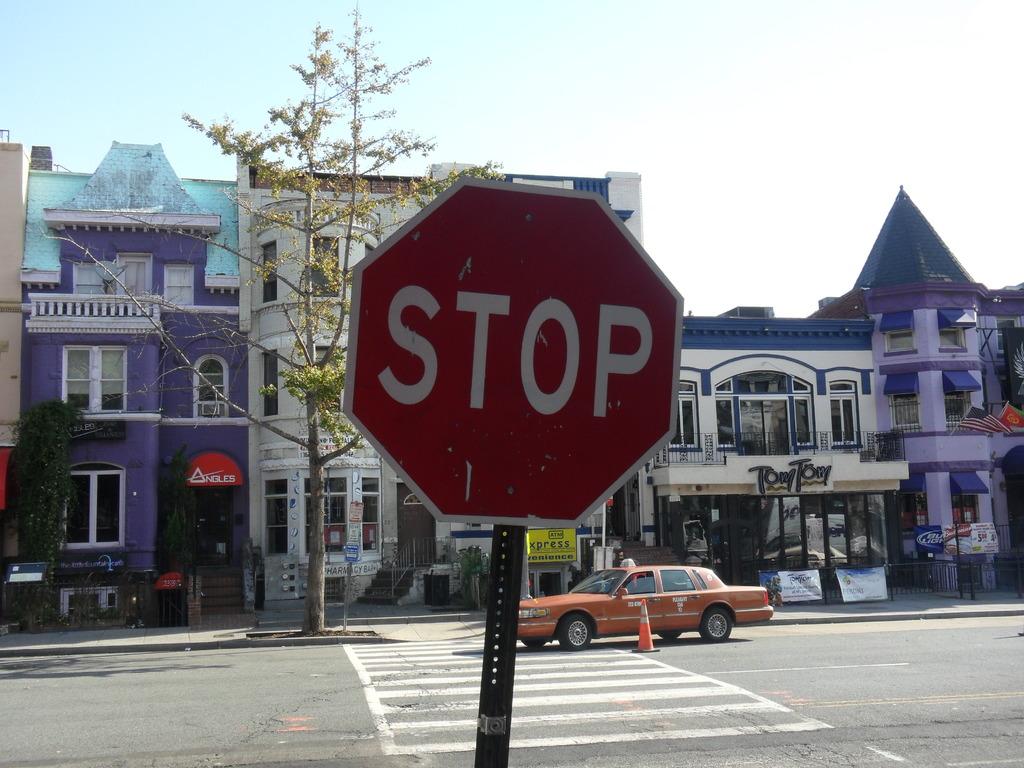What kind of street sign is in the photo?
Your answer should be compact. Stop. What business is behind and to the right of the stop sign?
Give a very brief answer. Tony tony. 